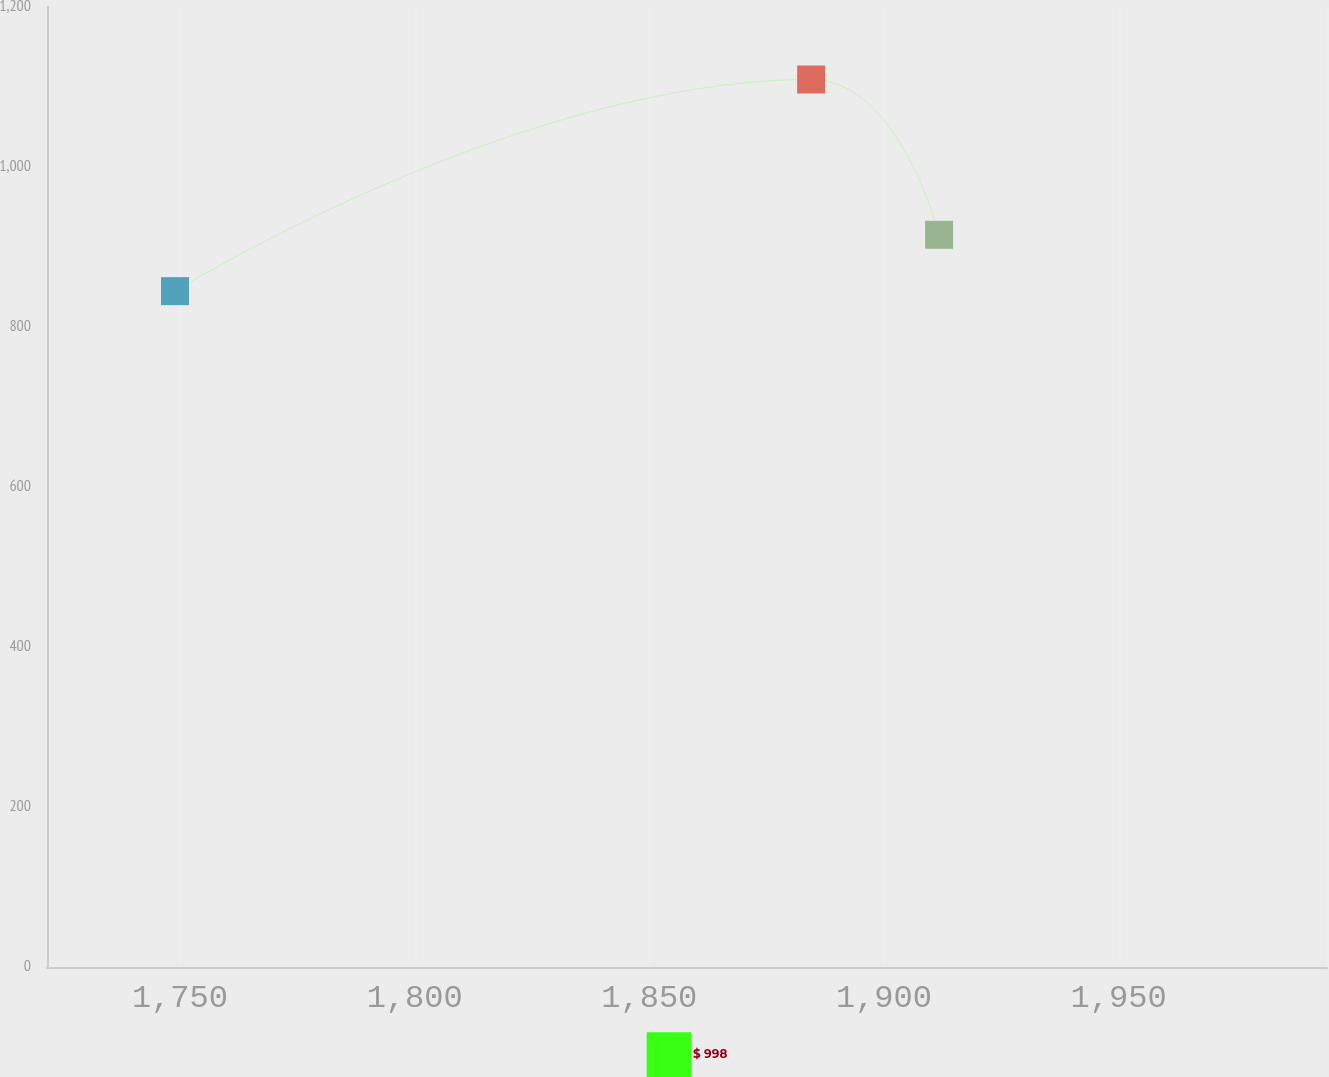Convert chart. <chart><loc_0><loc_0><loc_500><loc_500><line_chart><ecel><fcel>$ 998<nl><fcel>1748.94<fcel>844.8<nl><fcel>1884.48<fcel>1109.39<nl><fcel>1911.75<fcel>915.29<nl><fcel>2021.67<fcel>1146.81<nl></chart> 